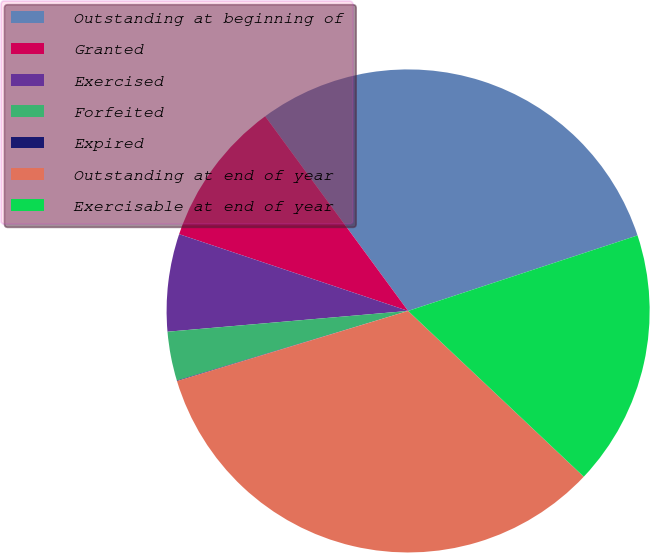Convert chart to OTSL. <chart><loc_0><loc_0><loc_500><loc_500><pie_chart><fcel>Outstanding at beginning of<fcel>Granted<fcel>Exercised<fcel>Forfeited<fcel>Expired<fcel>Outstanding at end of year<fcel>Exercisable at end of year<nl><fcel>30.02%<fcel>9.77%<fcel>6.52%<fcel>3.28%<fcel>0.04%<fcel>33.27%<fcel>17.1%<nl></chart> 